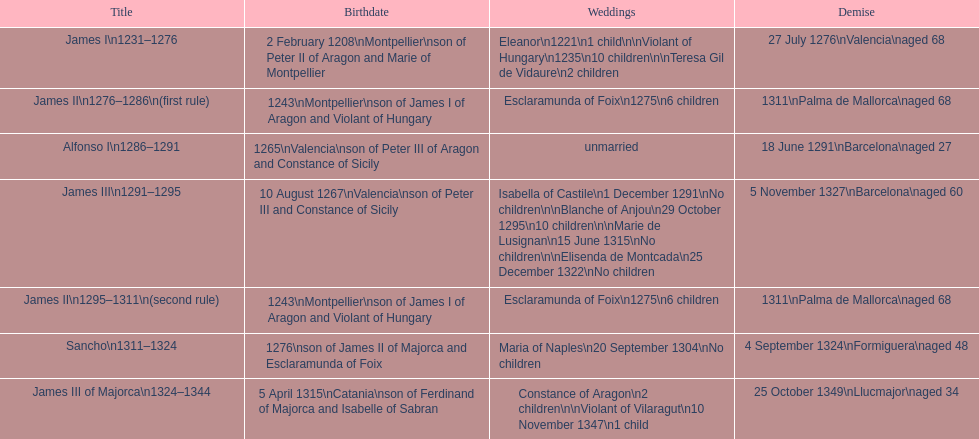Which two monarchs had no children? Alfonso I, Sancho. 